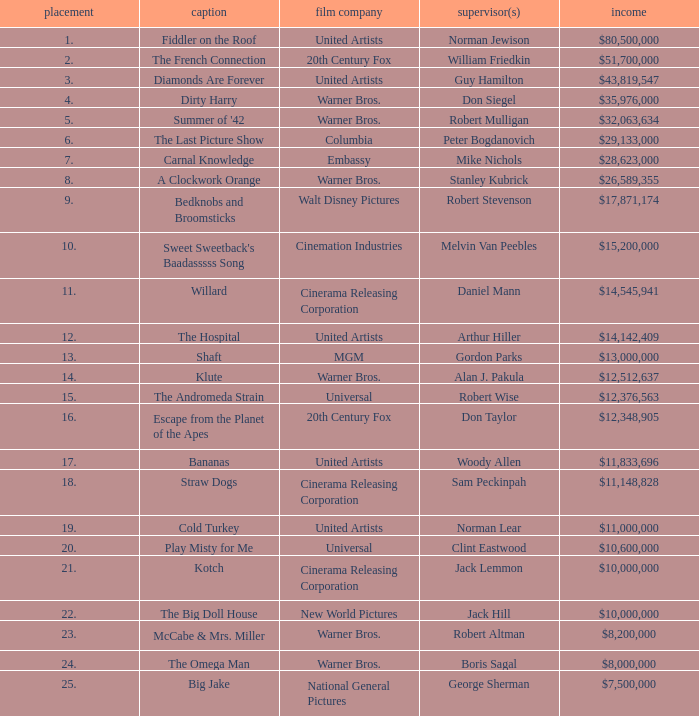What is the rank of The Big Doll House? 22.0. Parse the full table. {'header': ['placement', 'caption', 'film company', 'supervisor(s)', 'income'], 'rows': [['1.', 'Fiddler on the Roof', 'United Artists', 'Norman Jewison', '$80,500,000'], ['2.', 'The French Connection', '20th Century Fox', 'William Friedkin', '$51,700,000'], ['3.', 'Diamonds Are Forever', 'United Artists', 'Guy Hamilton', '$43,819,547'], ['4.', 'Dirty Harry', 'Warner Bros.', 'Don Siegel', '$35,976,000'], ['5.', "Summer of '42", 'Warner Bros.', 'Robert Mulligan', '$32,063,634'], ['6.', 'The Last Picture Show', 'Columbia', 'Peter Bogdanovich', '$29,133,000'], ['7.', 'Carnal Knowledge', 'Embassy', 'Mike Nichols', '$28,623,000'], ['8.', 'A Clockwork Orange', 'Warner Bros.', 'Stanley Kubrick', '$26,589,355'], ['9.', 'Bedknobs and Broomsticks', 'Walt Disney Pictures', 'Robert Stevenson', '$17,871,174'], ['10.', "Sweet Sweetback's Baadasssss Song", 'Cinemation Industries', 'Melvin Van Peebles', '$15,200,000'], ['11.', 'Willard', 'Cinerama Releasing Corporation', 'Daniel Mann', '$14,545,941'], ['12.', 'The Hospital', 'United Artists', 'Arthur Hiller', '$14,142,409'], ['13.', 'Shaft', 'MGM', 'Gordon Parks', '$13,000,000'], ['14.', 'Klute', 'Warner Bros.', 'Alan J. Pakula', '$12,512,637'], ['15.', 'The Andromeda Strain', 'Universal', 'Robert Wise', '$12,376,563'], ['16.', 'Escape from the Planet of the Apes', '20th Century Fox', 'Don Taylor', '$12,348,905'], ['17.', 'Bananas', 'United Artists', 'Woody Allen', '$11,833,696'], ['18.', 'Straw Dogs', 'Cinerama Releasing Corporation', 'Sam Peckinpah', '$11,148,828'], ['19.', 'Cold Turkey', 'United Artists', 'Norman Lear', '$11,000,000'], ['20.', 'Play Misty for Me', 'Universal', 'Clint Eastwood', '$10,600,000'], ['21.', 'Kotch', 'Cinerama Releasing Corporation', 'Jack Lemmon', '$10,000,000'], ['22.', 'The Big Doll House', 'New World Pictures', 'Jack Hill', '$10,000,000'], ['23.', 'McCabe & Mrs. Miller', 'Warner Bros.', 'Robert Altman', '$8,200,000'], ['24.', 'The Omega Man', 'Warner Bros.', 'Boris Sagal', '$8,000,000'], ['25.', 'Big Jake', 'National General Pictures', 'George Sherman', '$7,500,000']]} 